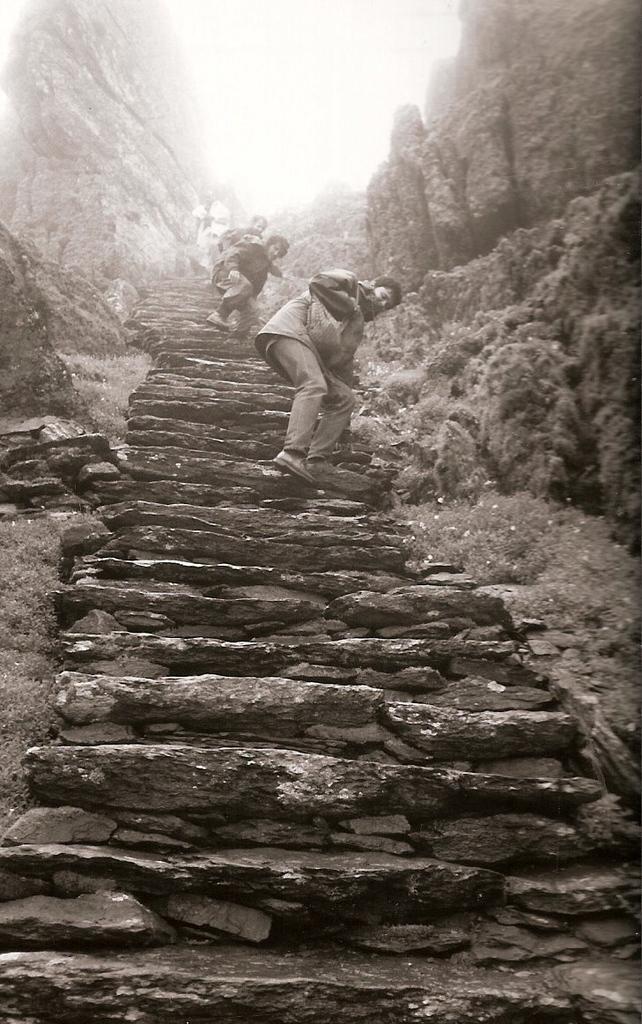Describe this image in one or two sentences. This image is a black and white image. In the middle of the image there are a few steps and a few people are climbing the steps. In the background there are many rocks. 